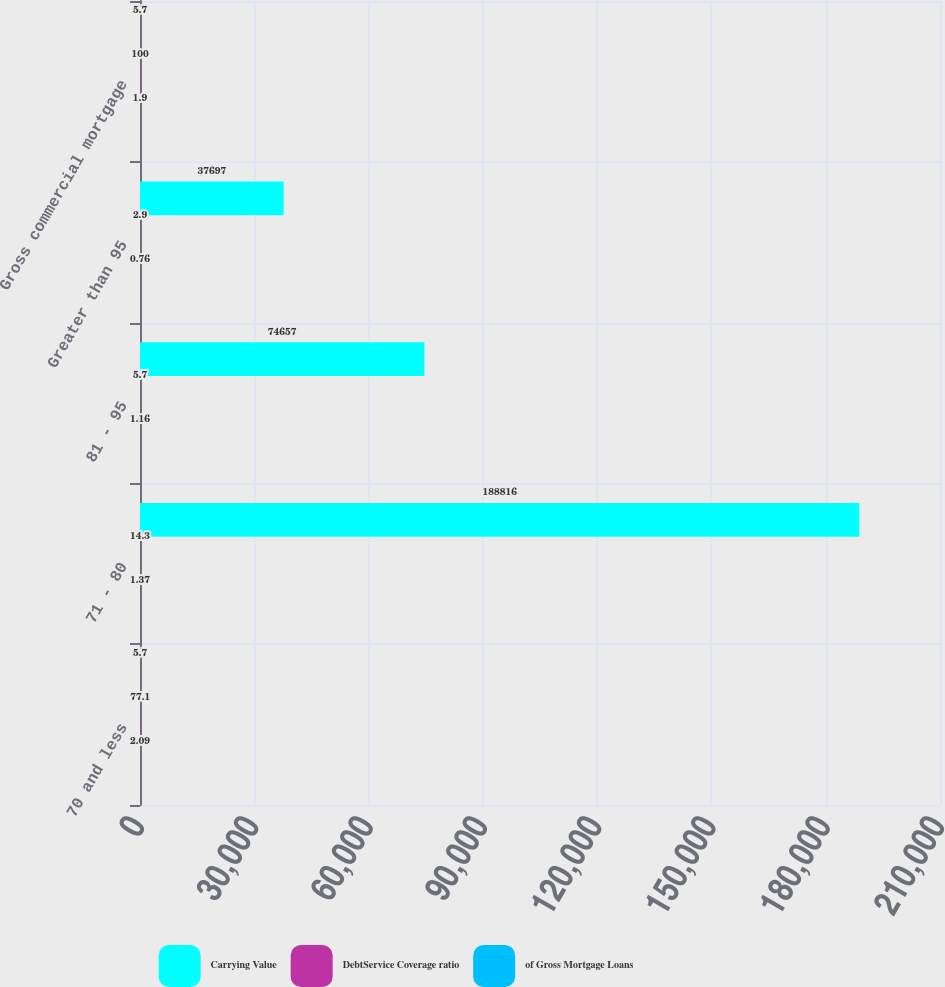<chart> <loc_0><loc_0><loc_500><loc_500><stacked_bar_chart><ecel><fcel>70 and less<fcel>71 - 80<fcel>81 - 95<fcel>Greater than 95<fcel>Gross commercial mortgage<nl><fcel>Carrying Value<fcel>5.7<fcel>188816<fcel>74657<fcel>37697<fcel>5.7<nl><fcel>DebtService Coverage ratio<fcel>77.1<fcel>14.3<fcel>5.7<fcel>2.9<fcel>100<nl><fcel>of Gross Mortgage Loans<fcel>2.09<fcel>1.37<fcel>1.16<fcel>0.76<fcel>1.9<nl></chart> 